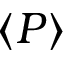<formula> <loc_0><loc_0><loc_500><loc_500>\langle { P } \rangle</formula> 